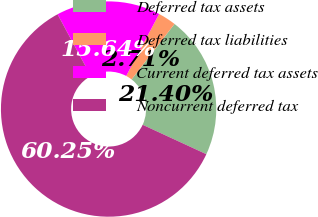<chart> <loc_0><loc_0><loc_500><loc_500><pie_chart><fcel>Deferred tax assets<fcel>Deferred tax liabilities<fcel>Current deferred tax assets<fcel>Noncurrent deferred tax<nl><fcel>21.4%<fcel>2.71%<fcel>15.64%<fcel>60.25%<nl></chart> 